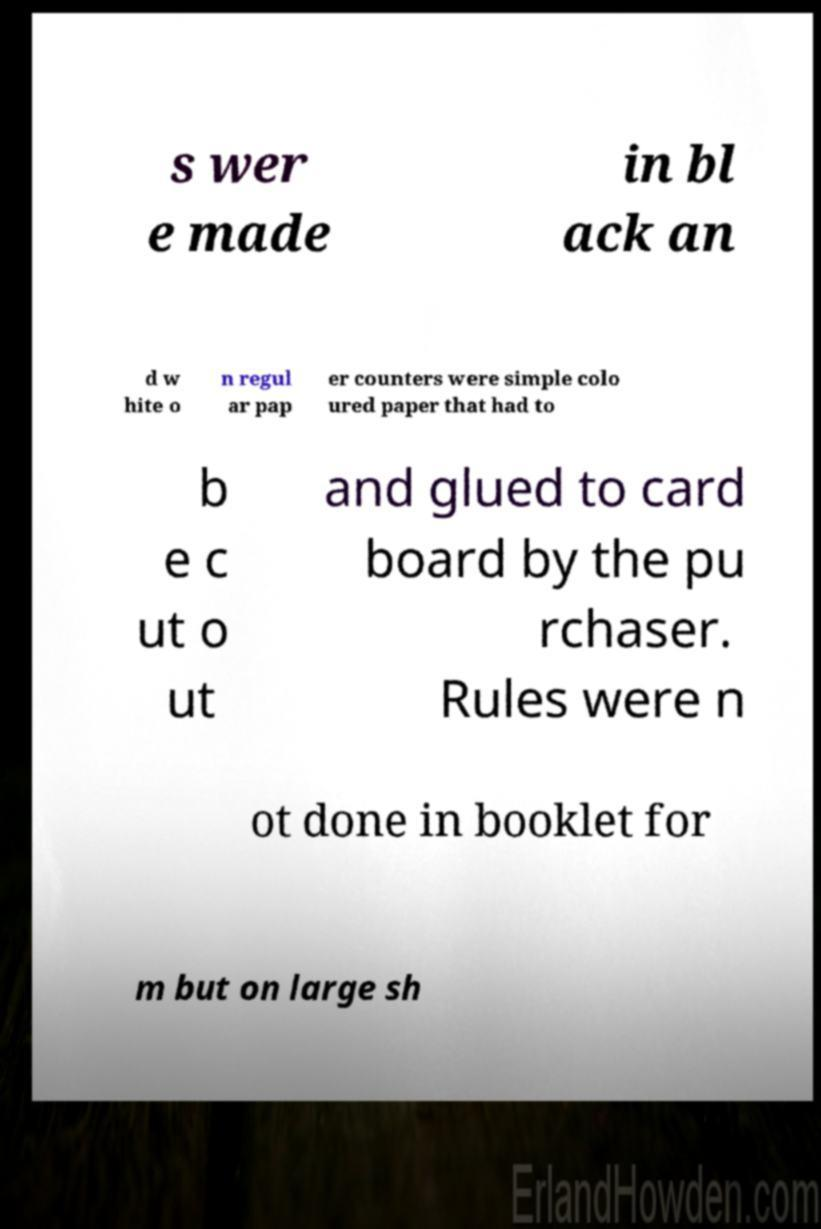There's text embedded in this image that I need extracted. Can you transcribe it verbatim? s wer e made in bl ack an d w hite o n regul ar pap er counters were simple colo ured paper that had to b e c ut o ut and glued to card board by the pu rchaser. Rules were n ot done in booklet for m but on large sh 